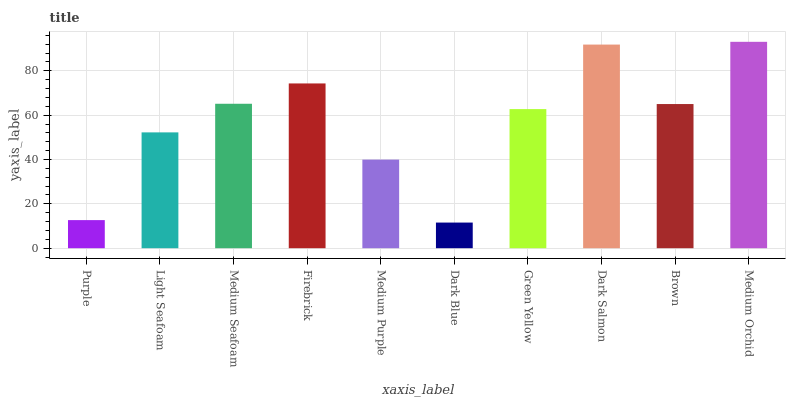Is Dark Blue the minimum?
Answer yes or no. Yes. Is Medium Orchid the maximum?
Answer yes or no. Yes. Is Light Seafoam the minimum?
Answer yes or no. No. Is Light Seafoam the maximum?
Answer yes or no. No. Is Light Seafoam greater than Purple?
Answer yes or no. Yes. Is Purple less than Light Seafoam?
Answer yes or no. Yes. Is Purple greater than Light Seafoam?
Answer yes or no. No. Is Light Seafoam less than Purple?
Answer yes or no. No. Is Brown the high median?
Answer yes or no. Yes. Is Green Yellow the low median?
Answer yes or no. Yes. Is Green Yellow the high median?
Answer yes or no. No. Is Medium Orchid the low median?
Answer yes or no. No. 